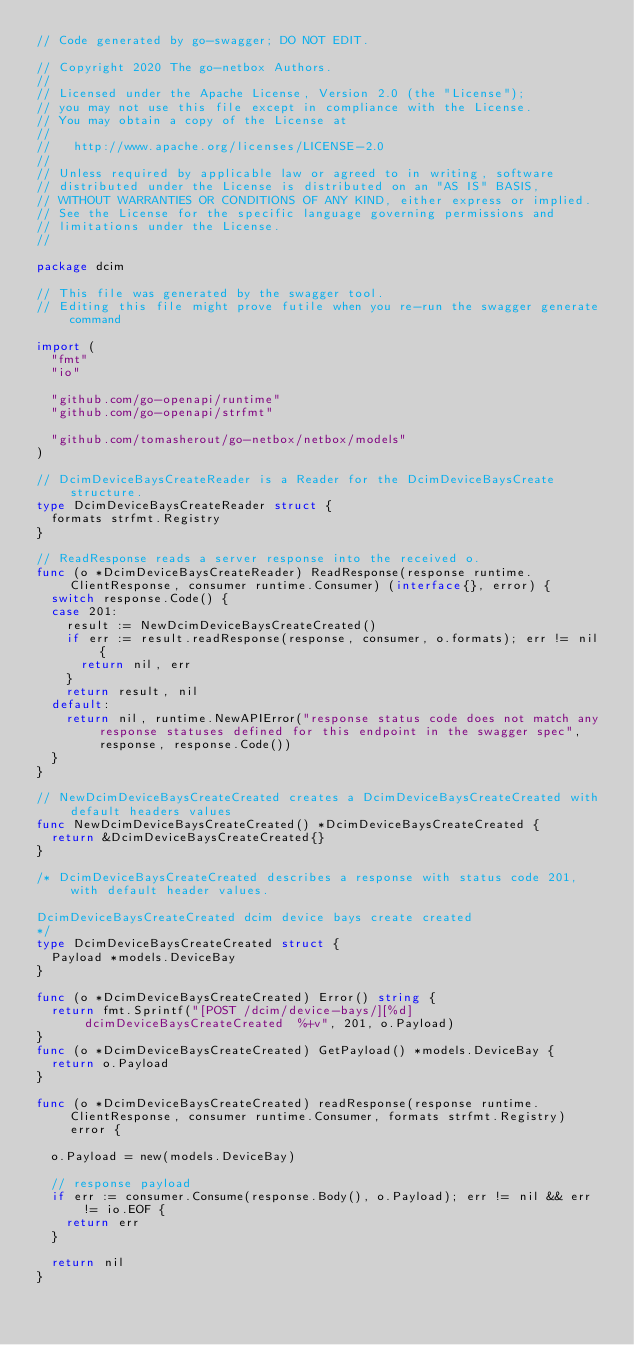<code> <loc_0><loc_0><loc_500><loc_500><_Go_>// Code generated by go-swagger; DO NOT EDIT.

// Copyright 2020 The go-netbox Authors.
//
// Licensed under the Apache License, Version 2.0 (the "License");
// you may not use this file except in compliance with the License.
// You may obtain a copy of the License at
//
//   http://www.apache.org/licenses/LICENSE-2.0
//
// Unless required by applicable law or agreed to in writing, software
// distributed under the License is distributed on an "AS IS" BASIS,
// WITHOUT WARRANTIES OR CONDITIONS OF ANY KIND, either express or implied.
// See the License for the specific language governing permissions and
// limitations under the License.
//

package dcim

// This file was generated by the swagger tool.
// Editing this file might prove futile when you re-run the swagger generate command

import (
	"fmt"
	"io"

	"github.com/go-openapi/runtime"
	"github.com/go-openapi/strfmt"

	"github.com/tomasherout/go-netbox/netbox/models"
)

// DcimDeviceBaysCreateReader is a Reader for the DcimDeviceBaysCreate structure.
type DcimDeviceBaysCreateReader struct {
	formats strfmt.Registry
}

// ReadResponse reads a server response into the received o.
func (o *DcimDeviceBaysCreateReader) ReadResponse(response runtime.ClientResponse, consumer runtime.Consumer) (interface{}, error) {
	switch response.Code() {
	case 201:
		result := NewDcimDeviceBaysCreateCreated()
		if err := result.readResponse(response, consumer, o.formats); err != nil {
			return nil, err
		}
		return result, nil
	default:
		return nil, runtime.NewAPIError("response status code does not match any response statuses defined for this endpoint in the swagger spec", response, response.Code())
	}
}

// NewDcimDeviceBaysCreateCreated creates a DcimDeviceBaysCreateCreated with default headers values
func NewDcimDeviceBaysCreateCreated() *DcimDeviceBaysCreateCreated {
	return &DcimDeviceBaysCreateCreated{}
}

/* DcimDeviceBaysCreateCreated describes a response with status code 201, with default header values.

DcimDeviceBaysCreateCreated dcim device bays create created
*/
type DcimDeviceBaysCreateCreated struct {
	Payload *models.DeviceBay
}

func (o *DcimDeviceBaysCreateCreated) Error() string {
	return fmt.Sprintf("[POST /dcim/device-bays/][%d] dcimDeviceBaysCreateCreated  %+v", 201, o.Payload)
}
func (o *DcimDeviceBaysCreateCreated) GetPayload() *models.DeviceBay {
	return o.Payload
}

func (o *DcimDeviceBaysCreateCreated) readResponse(response runtime.ClientResponse, consumer runtime.Consumer, formats strfmt.Registry) error {

	o.Payload = new(models.DeviceBay)

	// response payload
	if err := consumer.Consume(response.Body(), o.Payload); err != nil && err != io.EOF {
		return err
	}

	return nil
}
</code> 